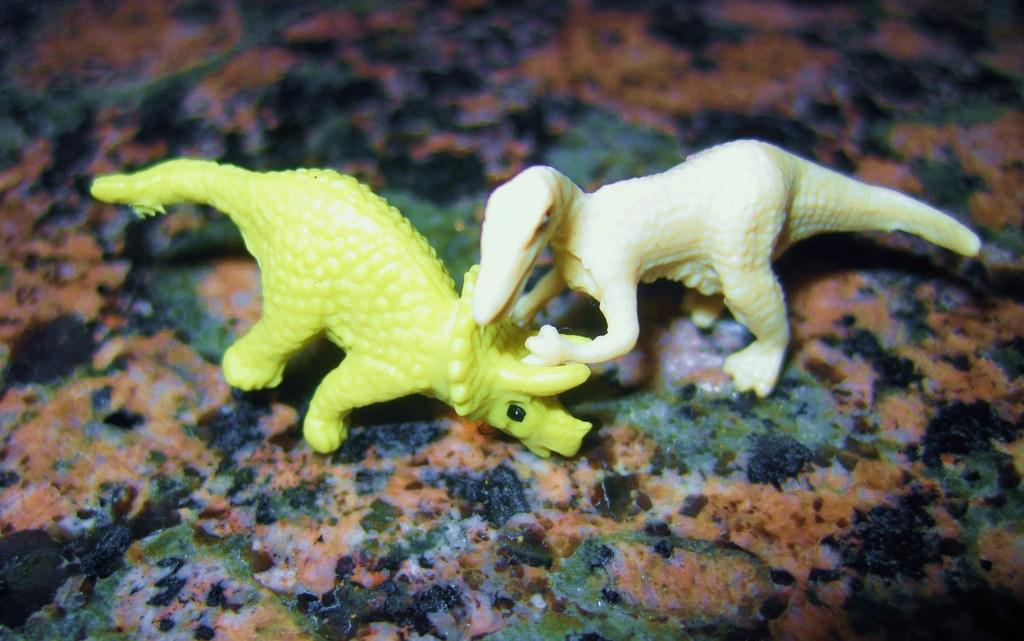What type of objects are present in the image? There are toy animals in the image. Where are the toy animals located? The toy animals are on a surface. What color is the paint on the window in the image? There is no mention of paint or a window in the image; it only features toy animals on a surface. 